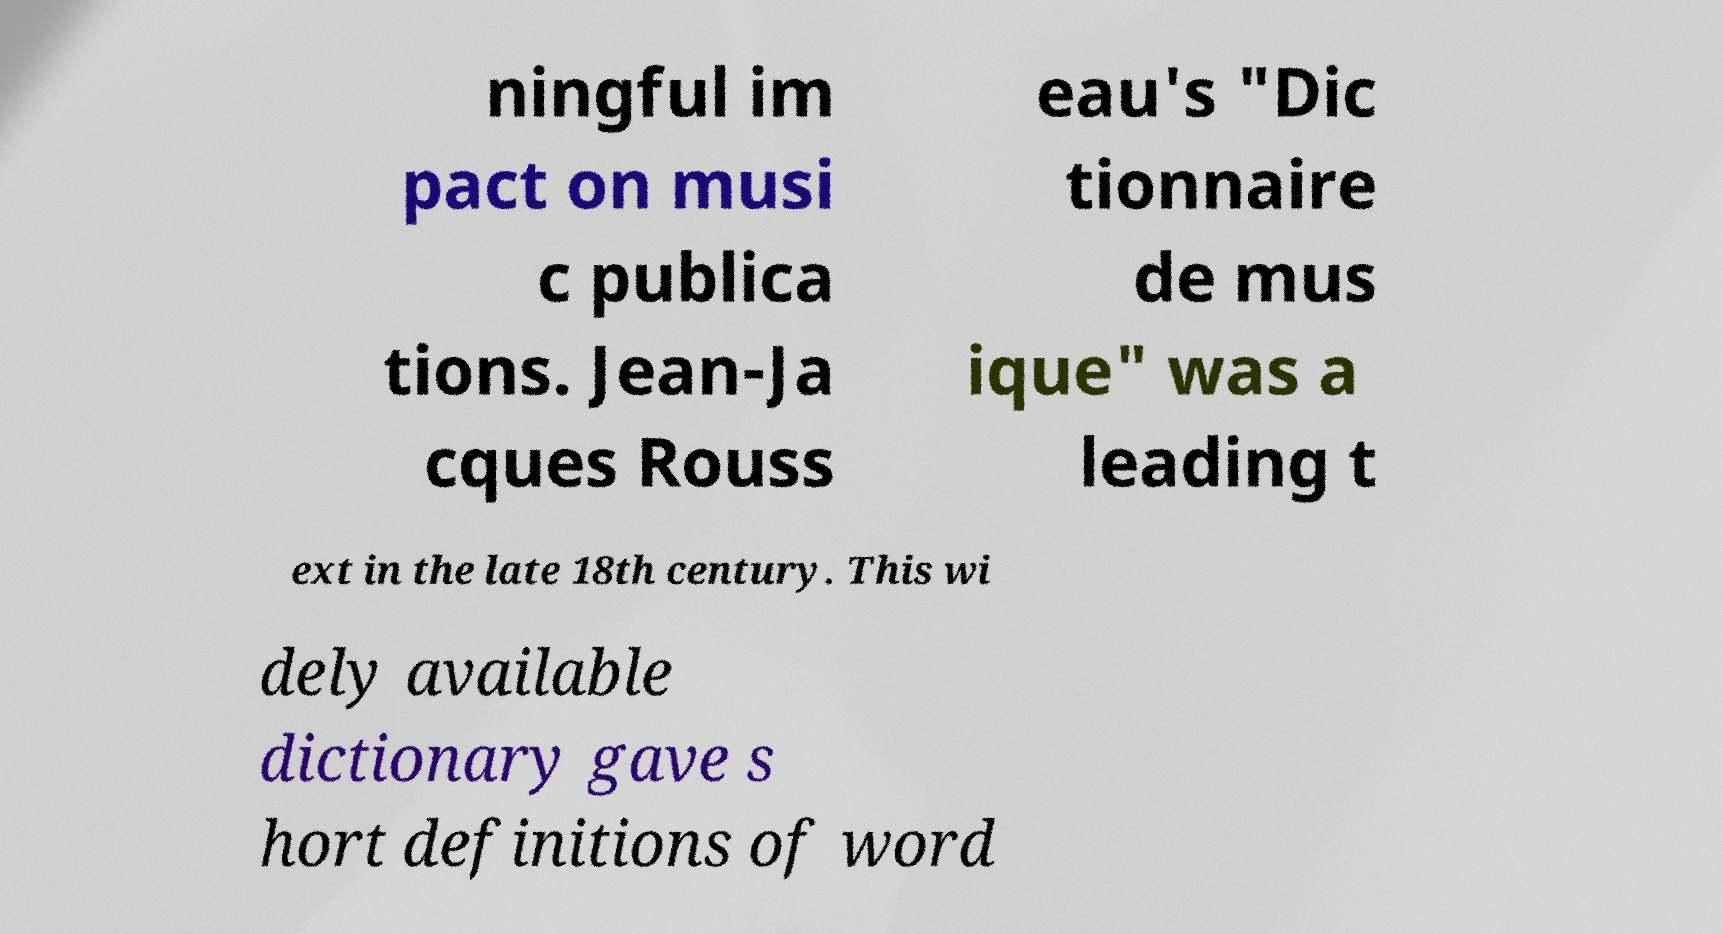Could you extract and type out the text from this image? ningful im pact on musi c publica tions. Jean-Ja cques Rouss eau's "Dic tionnaire de mus ique" was a leading t ext in the late 18th century. This wi dely available dictionary gave s hort definitions of word 